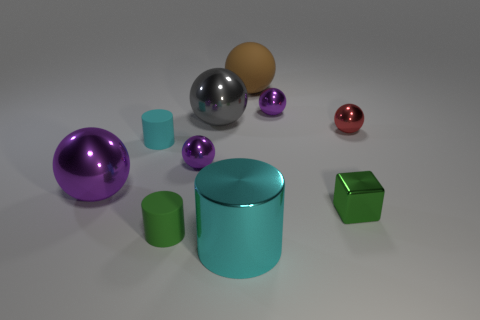Subtract all purple cubes. How many purple balls are left? 3 Subtract 3 spheres. How many spheres are left? 3 Subtract all red balls. How many balls are left? 5 Subtract all gray balls. How many balls are left? 5 Subtract all blue spheres. Subtract all red cylinders. How many spheres are left? 6 Subtract all spheres. How many objects are left? 4 Add 2 big shiny cylinders. How many big shiny cylinders exist? 3 Subtract 0 green spheres. How many objects are left? 10 Subtract all cyan metal cubes. Subtract all big gray metal things. How many objects are left? 9 Add 8 small red things. How many small red things are left? 9 